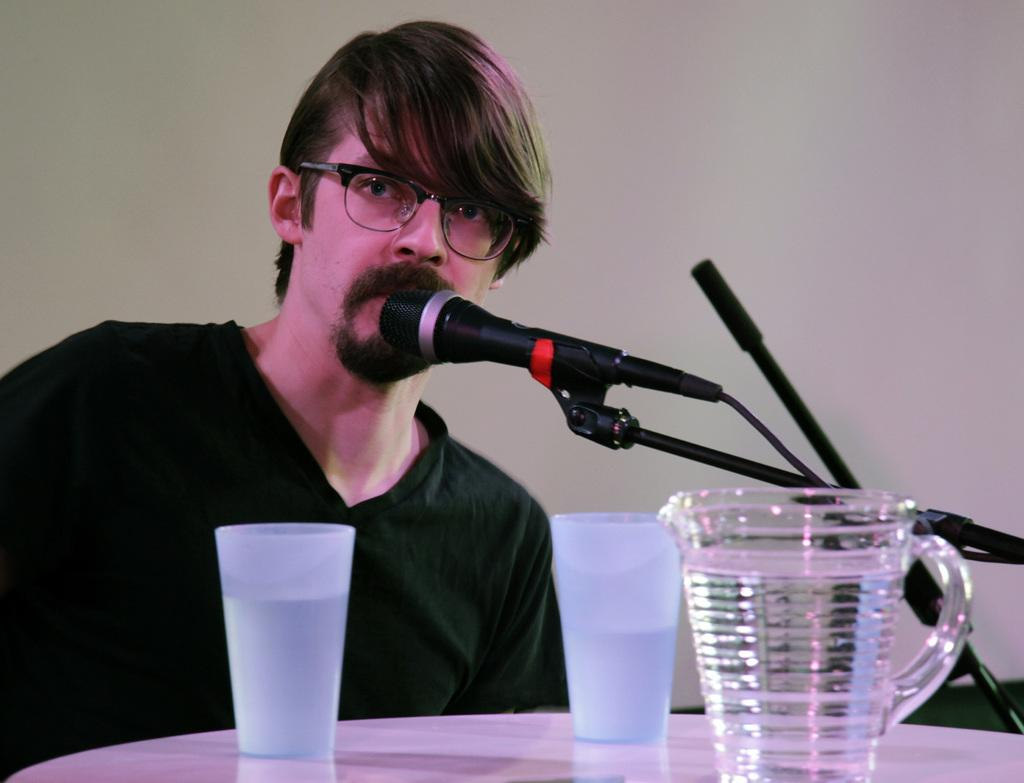Who is the main subject in the image? There is a man in the image. What can be seen on the man's face? The man is wearing spectacles. What objects are in front of the man? There are glasses, a jug, and a microphone in front of the man. What color is the man's t-shirt? The man is wearing a black color t-shirt. What type of van is parked behind the man in the image? There is no van present in the image. What musical instrument is the man playing in the image? The image does not show the man playing any musical instrument. 